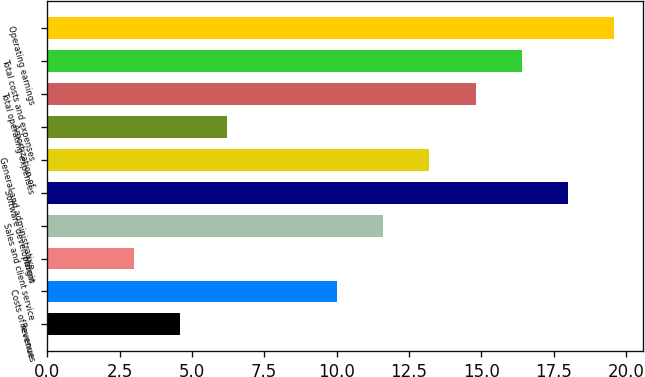Convert chart. <chart><loc_0><loc_0><loc_500><loc_500><bar_chart><fcel>Revenues<fcel>Costs of revenue<fcel>Margin<fcel>Sales and client service<fcel>Software development<fcel>General and administrative<fcel>Amortization of<fcel>Total operating expenses<fcel>Total costs and expenses<fcel>Operating earnings<nl><fcel>4.6<fcel>10<fcel>3<fcel>11.6<fcel>18<fcel>13.2<fcel>6.2<fcel>14.8<fcel>16.4<fcel>19.6<nl></chart> 